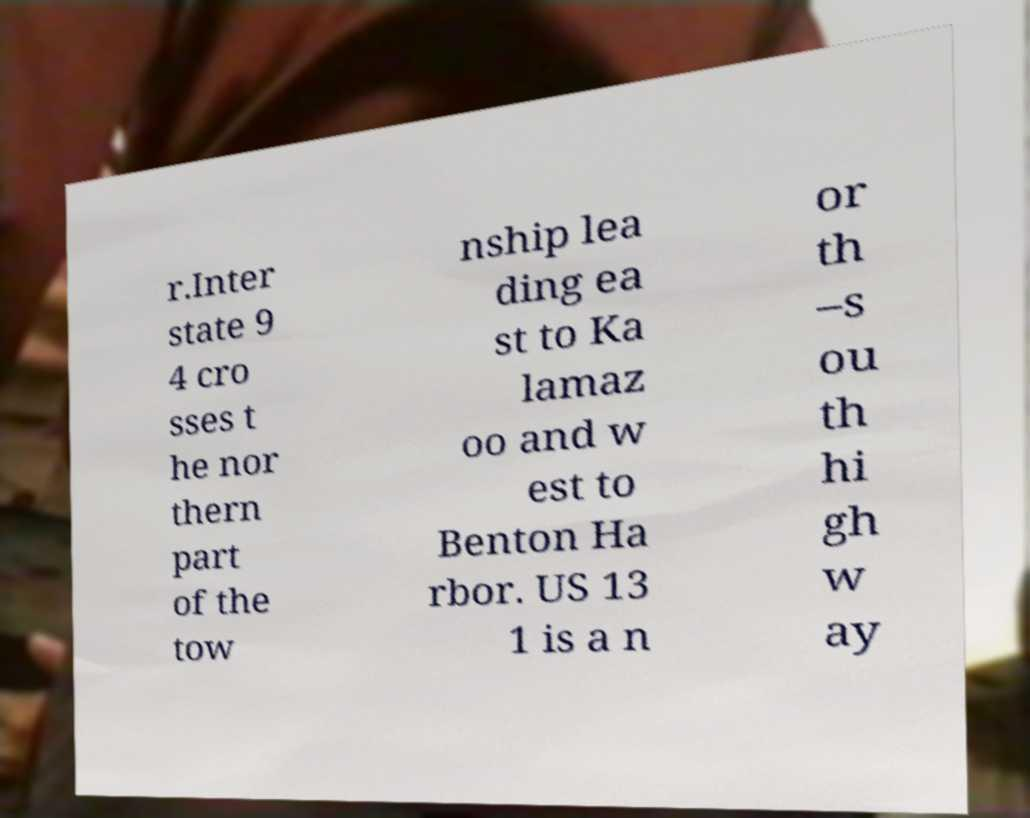Please read and relay the text visible in this image. What does it say? r.Inter state 9 4 cro sses t he nor thern part of the tow nship lea ding ea st to Ka lamaz oo and w est to Benton Ha rbor. US 13 1 is a n or th –s ou th hi gh w ay 